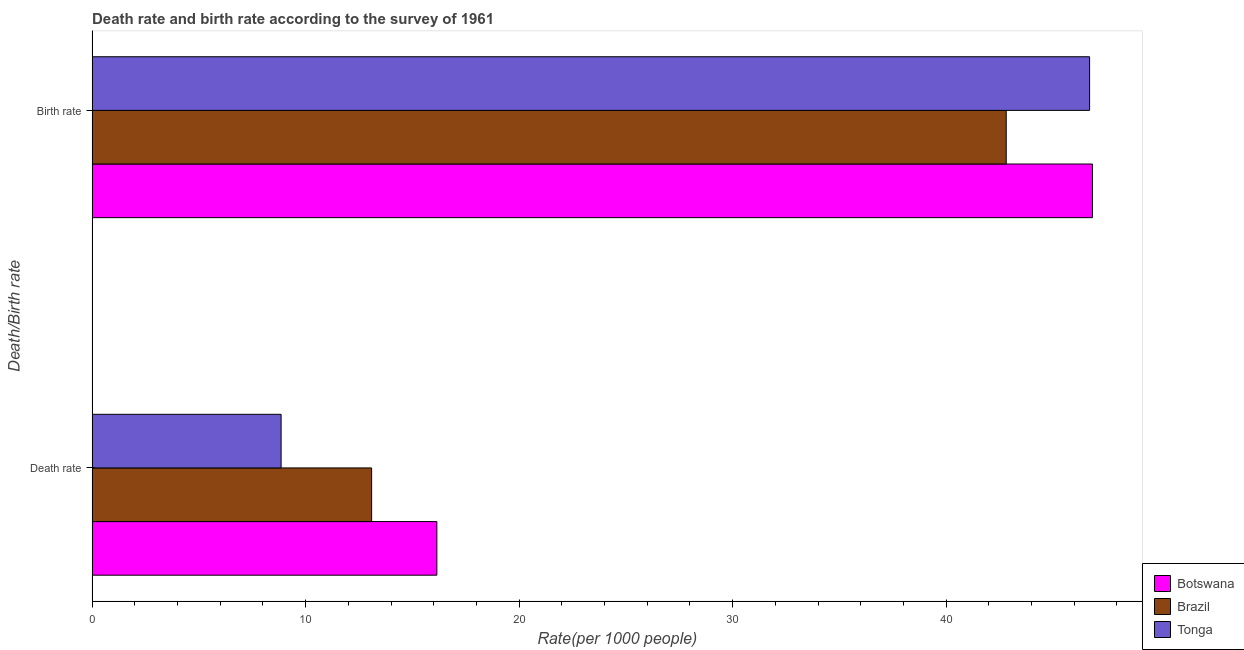How many different coloured bars are there?
Your response must be concise. 3. Are the number of bars on each tick of the Y-axis equal?
Your answer should be compact. Yes. What is the label of the 2nd group of bars from the top?
Offer a very short reply. Death rate. What is the death rate in Tonga?
Ensure brevity in your answer.  8.85. Across all countries, what is the maximum birth rate?
Offer a terse response. 46.85. Across all countries, what is the minimum birth rate?
Ensure brevity in your answer.  42.82. In which country was the death rate maximum?
Your answer should be very brief. Botswana. In which country was the birth rate minimum?
Provide a succinct answer. Brazil. What is the total death rate in the graph?
Give a very brief answer. 38.09. What is the difference between the birth rate in Botswana and that in Tonga?
Your answer should be compact. 0.13. What is the difference between the birth rate in Tonga and the death rate in Brazil?
Offer a terse response. 33.63. What is the average death rate per country?
Your answer should be compact. 12.7. What is the difference between the birth rate and death rate in Botswana?
Your answer should be very brief. 30.71. In how many countries, is the death rate greater than 28 ?
Give a very brief answer. 0. What is the ratio of the birth rate in Tonga to that in Botswana?
Provide a succinct answer. 1. In how many countries, is the birth rate greater than the average birth rate taken over all countries?
Provide a short and direct response. 2. What does the 3rd bar from the top in Birth rate represents?
Provide a succinct answer. Botswana. What does the 1st bar from the bottom in Birth rate represents?
Offer a very short reply. Botswana. What is the difference between two consecutive major ticks on the X-axis?
Provide a short and direct response. 10. Are the values on the major ticks of X-axis written in scientific E-notation?
Give a very brief answer. No. Does the graph contain any zero values?
Your answer should be very brief. No. Does the graph contain grids?
Offer a terse response. No. How are the legend labels stacked?
Give a very brief answer. Vertical. What is the title of the graph?
Provide a short and direct response. Death rate and birth rate according to the survey of 1961. What is the label or title of the X-axis?
Your answer should be very brief. Rate(per 1000 people). What is the label or title of the Y-axis?
Give a very brief answer. Death/Birth rate. What is the Rate(per 1000 people) of Botswana in Death rate?
Offer a very short reply. 16.15. What is the Rate(per 1000 people) in Brazil in Death rate?
Provide a succinct answer. 13.09. What is the Rate(per 1000 people) of Tonga in Death rate?
Keep it short and to the point. 8.85. What is the Rate(per 1000 people) of Botswana in Birth rate?
Offer a terse response. 46.85. What is the Rate(per 1000 people) of Brazil in Birth rate?
Make the answer very short. 42.82. What is the Rate(per 1000 people) in Tonga in Birth rate?
Offer a terse response. 46.72. Across all Death/Birth rate, what is the maximum Rate(per 1000 people) in Botswana?
Make the answer very short. 46.85. Across all Death/Birth rate, what is the maximum Rate(per 1000 people) of Brazil?
Provide a succinct answer. 42.82. Across all Death/Birth rate, what is the maximum Rate(per 1000 people) in Tonga?
Your response must be concise. 46.72. Across all Death/Birth rate, what is the minimum Rate(per 1000 people) in Botswana?
Make the answer very short. 16.15. Across all Death/Birth rate, what is the minimum Rate(per 1000 people) of Brazil?
Keep it short and to the point. 13.09. Across all Death/Birth rate, what is the minimum Rate(per 1000 people) of Tonga?
Keep it short and to the point. 8.85. What is the total Rate(per 1000 people) in Botswana in the graph?
Provide a short and direct response. 63. What is the total Rate(per 1000 people) of Brazil in the graph?
Ensure brevity in your answer.  55.91. What is the total Rate(per 1000 people) in Tonga in the graph?
Offer a terse response. 55.57. What is the difference between the Rate(per 1000 people) in Botswana in Death rate and that in Birth rate?
Offer a terse response. -30.71. What is the difference between the Rate(per 1000 people) of Brazil in Death rate and that in Birth rate?
Ensure brevity in your answer.  -29.72. What is the difference between the Rate(per 1000 people) of Tonga in Death rate and that in Birth rate?
Your answer should be very brief. -37.87. What is the difference between the Rate(per 1000 people) in Botswana in Death rate and the Rate(per 1000 people) in Brazil in Birth rate?
Your answer should be compact. -26.67. What is the difference between the Rate(per 1000 people) of Botswana in Death rate and the Rate(per 1000 people) of Tonga in Birth rate?
Your answer should be very brief. -30.57. What is the difference between the Rate(per 1000 people) in Brazil in Death rate and the Rate(per 1000 people) in Tonga in Birth rate?
Your answer should be very brief. -33.63. What is the average Rate(per 1000 people) of Botswana per Death/Birth rate?
Ensure brevity in your answer.  31.5. What is the average Rate(per 1000 people) in Brazil per Death/Birth rate?
Provide a short and direct response. 27.95. What is the average Rate(per 1000 people) in Tonga per Death/Birth rate?
Ensure brevity in your answer.  27.79. What is the difference between the Rate(per 1000 people) of Botswana and Rate(per 1000 people) of Brazil in Death rate?
Ensure brevity in your answer.  3.06. What is the difference between the Rate(per 1000 people) in Botswana and Rate(per 1000 people) in Tonga in Death rate?
Make the answer very short. 7.29. What is the difference between the Rate(per 1000 people) in Brazil and Rate(per 1000 people) in Tonga in Death rate?
Your answer should be very brief. 4.24. What is the difference between the Rate(per 1000 people) of Botswana and Rate(per 1000 people) of Brazil in Birth rate?
Your answer should be compact. 4.04. What is the difference between the Rate(per 1000 people) of Botswana and Rate(per 1000 people) of Tonga in Birth rate?
Offer a terse response. 0.13. What is the difference between the Rate(per 1000 people) of Brazil and Rate(per 1000 people) of Tonga in Birth rate?
Offer a terse response. -3.9. What is the ratio of the Rate(per 1000 people) of Botswana in Death rate to that in Birth rate?
Keep it short and to the point. 0.34. What is the ratio of the Rate(per 1000 people) of Brazil in Death rate to that in Birth rate?
Provide a succinct answer. 0.31. What is the ratio of the Rate(per 1000 people) in Tonga in Death rate to that in Birth rate?
Ensure brevity in your answer.  0.19. What is the difference between the highest and the second highest Rate(per 1000 people) of Botswana?
Give a very brief answer. 30.71. What is the difference between the highest and the second highest Rate(per 1000 people) of Brazil?
Provide a succinct answer. 29.72. What is the difference between the highest and the second highest Rate(per 1000 people) in Tonga?
Provide a short and direct response. 37.87. What is the difference between the highest and the lowest Rate(per 1000 people) of Botswana?
Provide a succinct answer. 30.71. What is the difference between the highest and the lowest Rate(per 1000 people) of Brazil?
Your answer should be compact. 29.72. What is the difference between the highest and the lowest Rate(per 1000 people) of Tonga?
Provide a short and direct response. 37.87. 